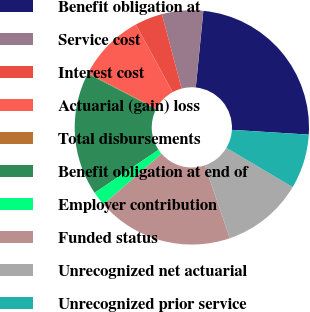Convert chart. <chart><loc_0><loc_0><loc_500><loc_500><pie_chart><fcel>Benefit obligation at<fcel>Service cost<fcel>Interest cost<fcel>Actuarial (gain) loss<fcel>Total disbursements<fcel>Benefit obligation at end of<fcel>Employer contribution<fcel>Funded status<fcel>Unrecognized net actuarial<fcel>Unrecognized prior service<nl><fcel>24.41%<fcel>5.68%<fcel>3.82%<fcel>9.38%<fcel>0.12%<fcel>17.0%<fcel>1.97%<fcel>18.86%<fcel>11.23%<fcel>7.53%<nl></chart> 